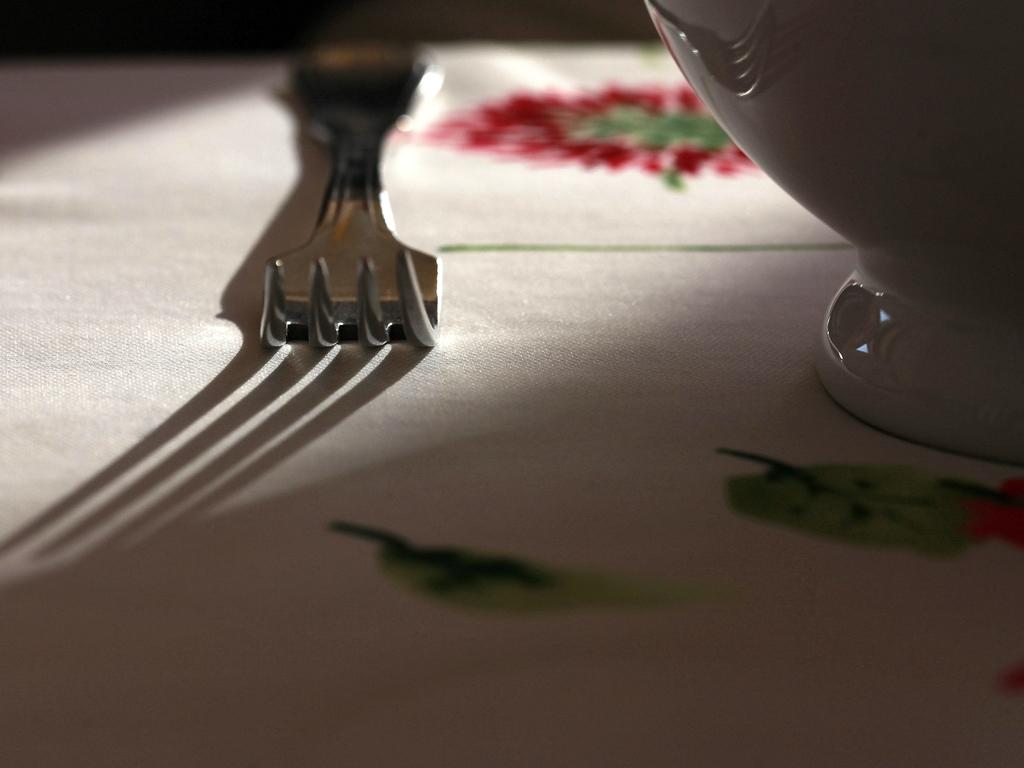What type of utensils can be seen in the image? There is a fork and a spoon in the image. What is the utensil used for holding or scooping food? The spoon is used for holding or scooping food. What is the utensil used for cutting or piercing food? The fork is used for cutting or piercing food. What is the surface on which the utensils are placed? The objects are placed on a white cloth. How does the stomach feel after consuming the food in the image? The image does not show anyone consuming food, nor does it provide any information about the stomach's feelings. 